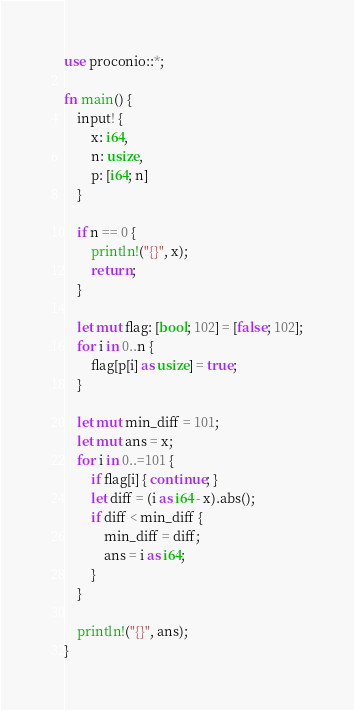Convert code to text. <code><loc_0><loc_0><loc_500><loc_500><_Rust_>use proconio::*;

fn main() {
    input! {
        x: i64,
        n: usize,
        p: [i64; n]
    }
    
    if n == 0 {
        println!("{}", x);
        return;
    }

    let mut flag: [bool; 102] = [false; 102];
    for i in 0..n {
        flag[p[i] as usize] = true;
    }

    let mut min_diff = 101;
    let mut ans = x;
    for i in 0..=101 {
        if flag[i] { continue; }
        let diff = (i as i64 - x).abs();
        if diff < min_diff {
            min_diff = diff;
            ans = i as i64;
        }
    }

    println!("{}", ans);
}
</code> 